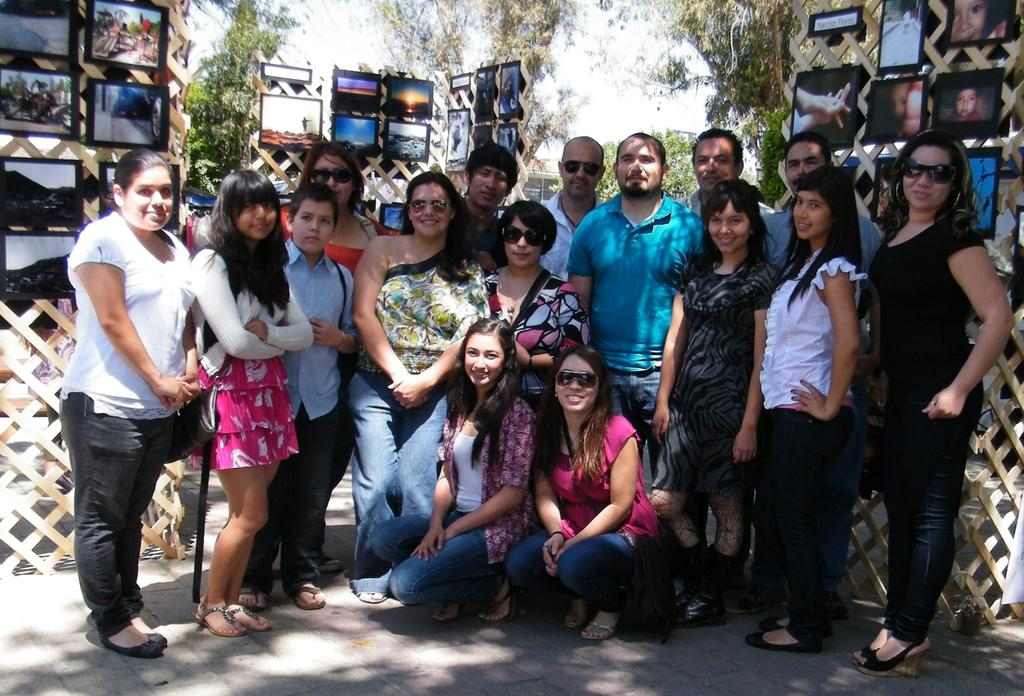Who is present in the image? There are people in the image. What are the people doing in the image? The people are standing and taking a picture. What objects are related to photography in the image? There are photo frames placed in the image. What type of range can be seen in the image? There is no range present in the image. Is there any smoke visible in the image? No, there is no smoke visible in the image. 